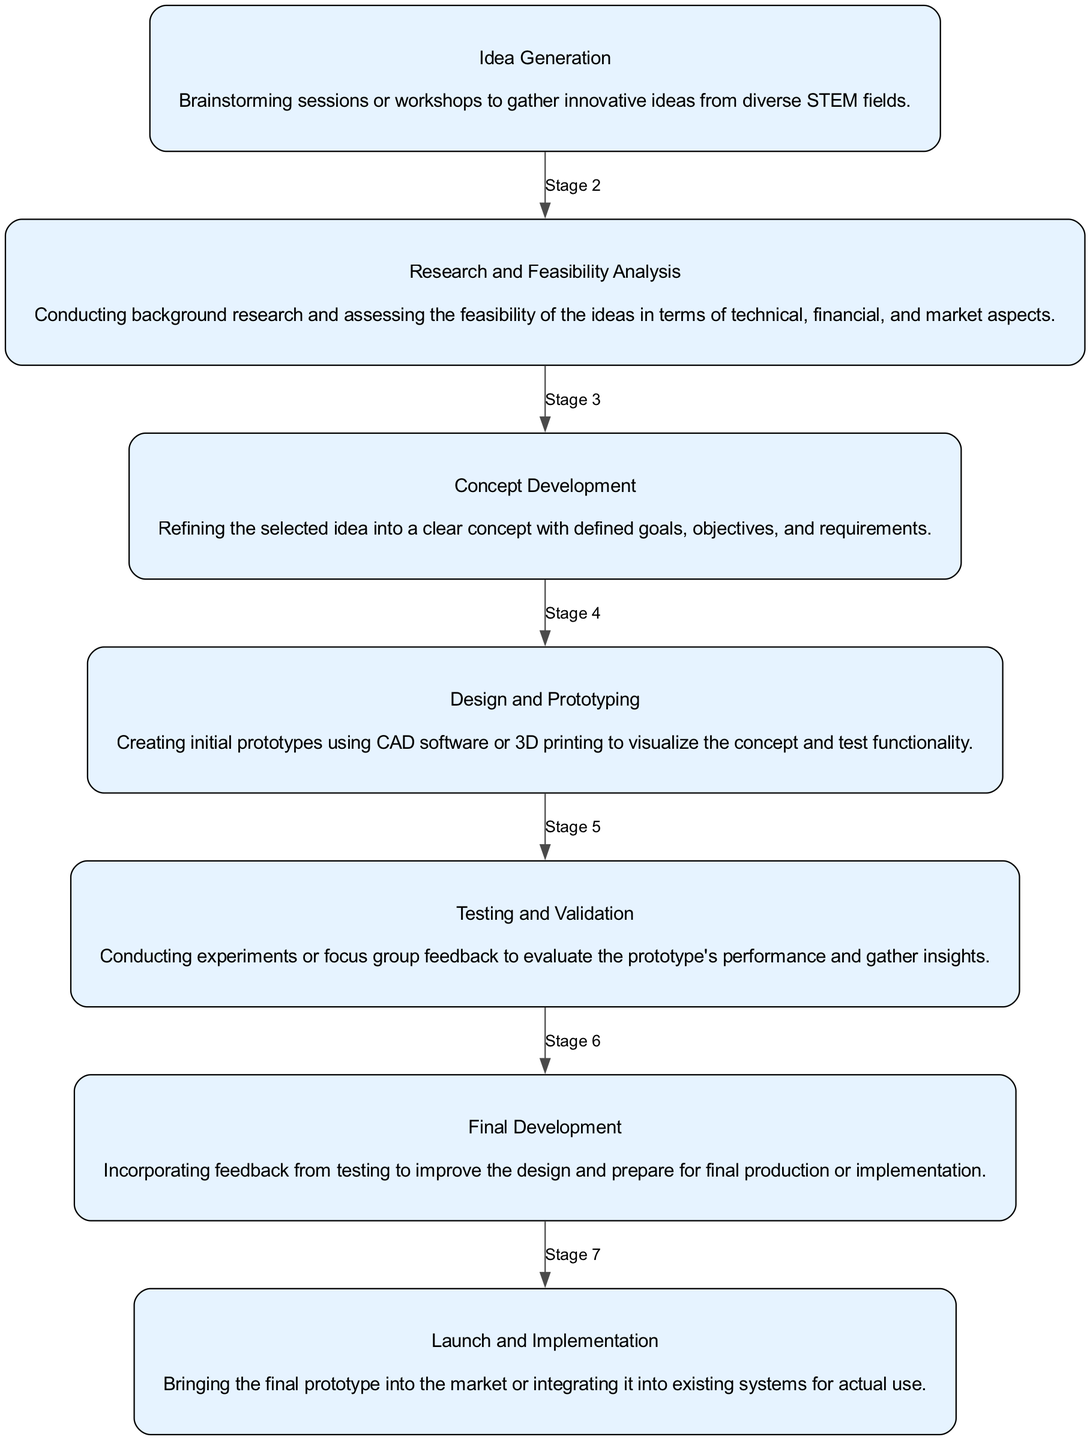What is the first stage of idea development? The flow chart starts with the "Idea Generation" stage, which is the first node in the series of stages listed.
Answer: Idea Generation How many stages are shown in the diagram? By counting the individual stages listed in the flow chart, there are a total of seven distinct stages indicating the process of idea development.
Answer: Seven What is the last stage of idea development? The final node in the diagram is labeled as "Launch and Implementation," which represents the last stage in the series of development.
Answer: Launch and Implementation What follows the "Research and Feasibility Analysis" stage? Analyzing the flow of the diagram, the "Concept Development" stage is directly connected as the next step after "Research and Feasibility Analysis."
Answer: Concept Development Which stage involves creating initial prototypes? The diagram specifies that the "Design and Prototyping" stage involves creating initial prototypes, indicating a focus on visualization and functionality testing.
Answer: Design and Prototyping What action is associated with the "Testing and Validation" stage? The description for the "Testing and Validation" stage indicates it involves conducting experiments or gathering feedback to assess the prototype's performance.
Answer: Conducting experiments or focus group feedback How many edges are present in the diagram? By analyzing the connections between each stage, each stage connects to the next with an edge, resulting in a total of six directed edges linking the seven stages.
Answer: Six Why is the "Final Development" stage significant? The "Final Development" stage is critical as it focuses on incorporating feedback received during testing to enhance the prototype, leading to improvement before production.
Answer: Incorporating feedback from testing What process follows "Design and Prototyping"? The flow chart shows that after "Design and Prototyping," the process moves on to "Testing and Validation," indicating the need for evaluating prototypes.
Answer: Testing and Validation 